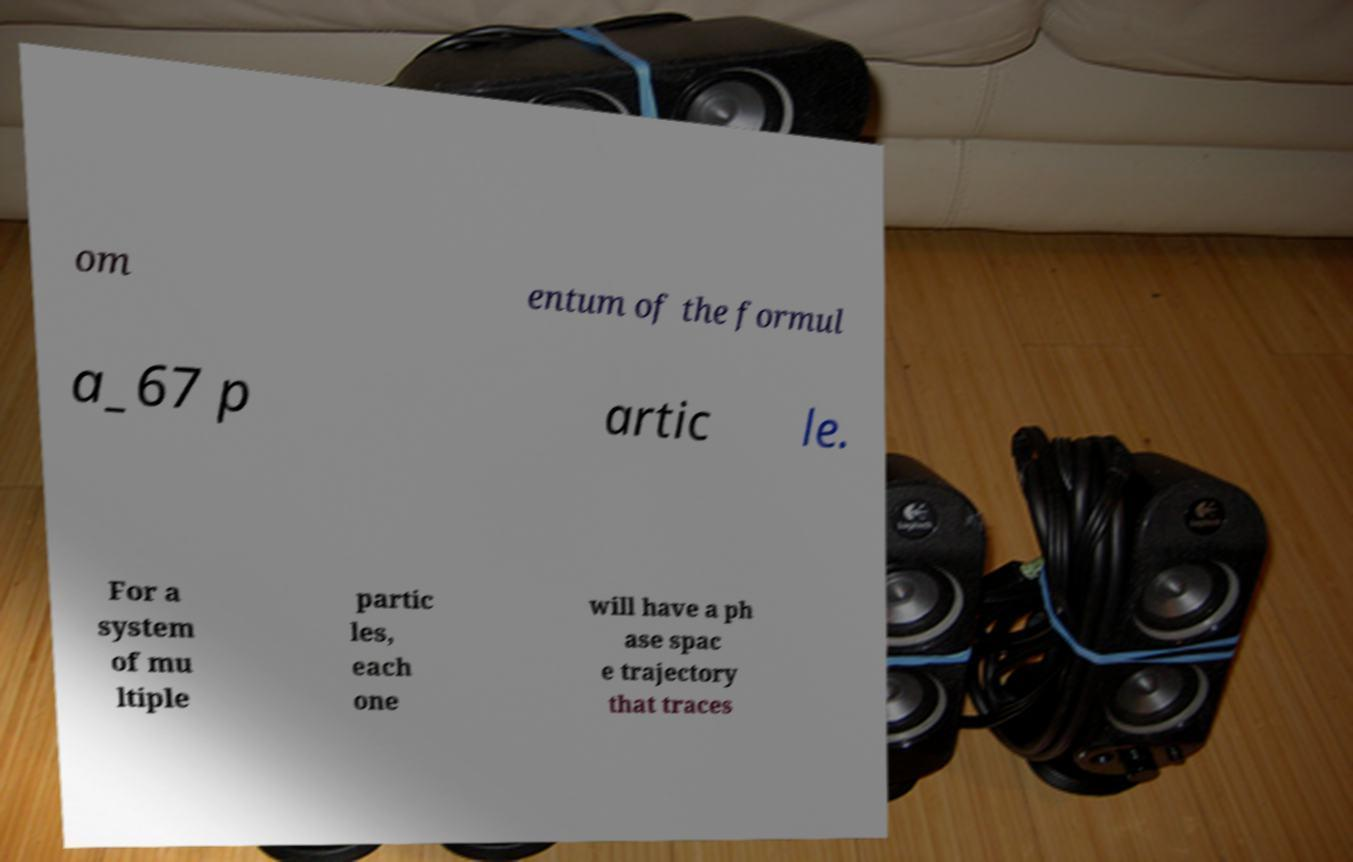Please read and relay the text visible in this image. What does it say? om entum of the formul a_67 p artic le. For a system of mu ltiple partic les, each one will have a ph ase spac e trajectory that traces 